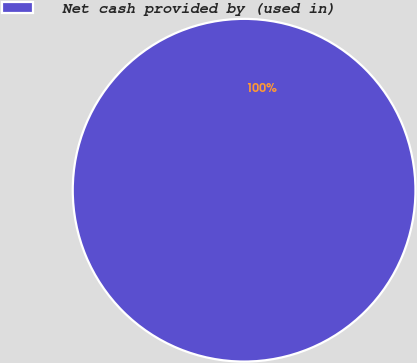Convert chart to OTSL. <chart><loc_0><loc_0><loc_500><loc_500><pie_chart><fcel>Net cash provided by (used in)<nl><fcel>100.0%<nl></chart> 